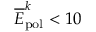<formula> <loc_0><loc_0><loc_500><loc_500>\overline { E } _ { p o l } ^ { k } < 1 0</formula> 